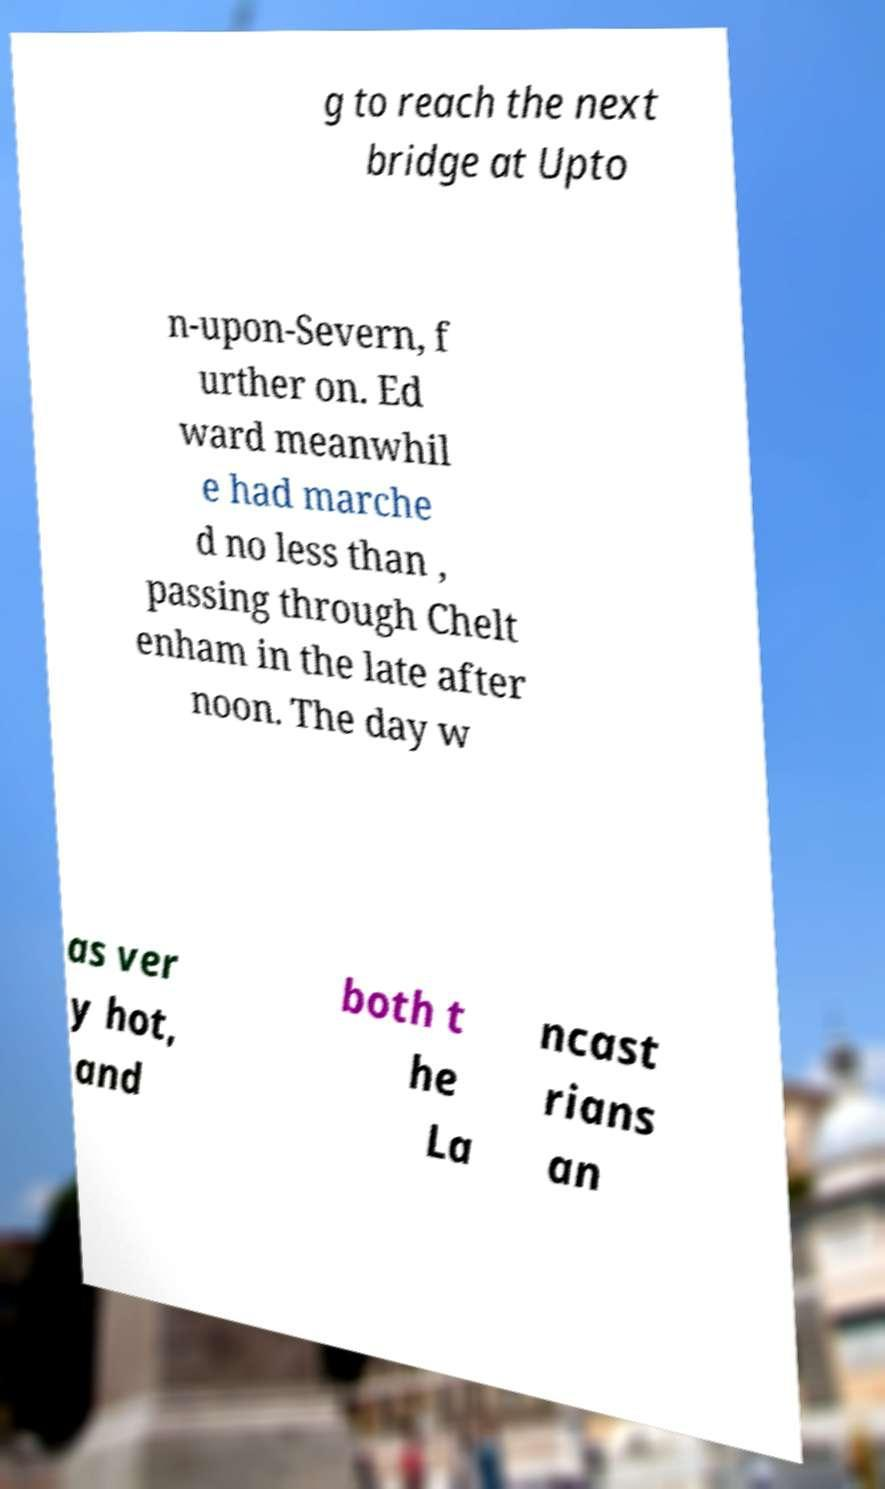What messages or text are displayed in this image? I need them in a readable, typed format. g to reach the next bridge at Upto n-upon-Severn, f urther on. Ed ward meanwhil e had marche d no less than , passing through Chelt enham in the late after noon. The day w as ver y hot, and both t he La ncast rians an 